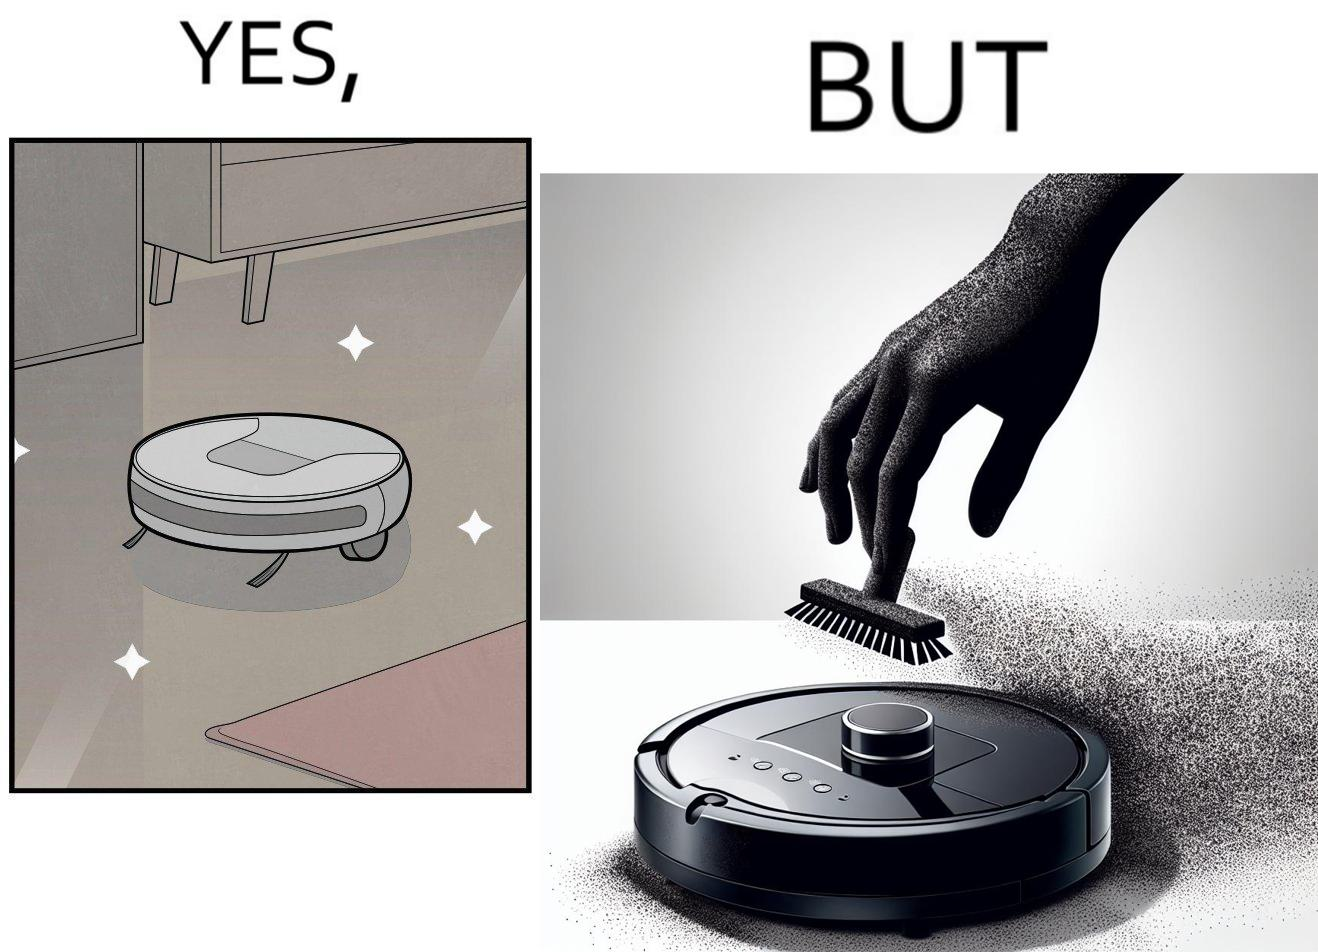Is this a satirical image? Yes, this image is satirical. 